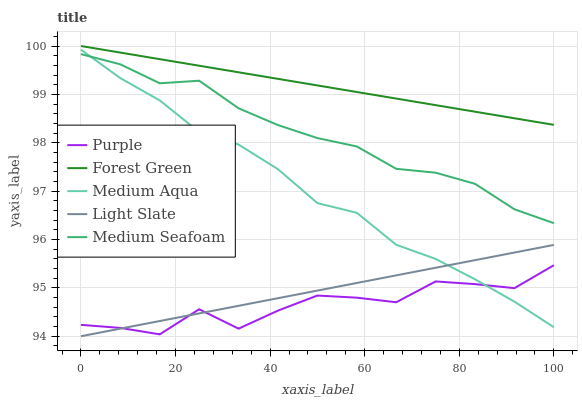Does Purple have the minimum area under the curve?
Answer yes or no. Yes. Does Forest Green have the maximum area under the curve?
Answer yes or no. Yes. Does Light Slate have the minimum area under the curve?
Answer yes or no. No. Does Light Slate have the maximum area under the curve?
Answer yes or no. No. Is Forest Green the smoothest?
Answer yes or no. Yes. Is Purple the roughest?
Answer yes or no. Yes. Is Light Slate the smoothest?
Answer yes or no. No. Is Light Slate the roughest?
Answer yes or no. No. Does Light Slate have the lowest value?
Answer yes or no. Yes. Does Forest Green have the lowest value?
Answer yes or no. No. Does Forest Green have the highest value?
Answer yes or no. Yes. Does Light Slate have the highest value?
Answer yes or no. No. Is Light Slate less than Medium Seafoam?
Answer yes or no. Yes. Is Forest Green greater than Medium Seafoam?
Answer yes or no. Yes. Does Purple intersect Light Slate?
Answer yes or no. Yes. Is Purple less than Light Slate?
Answer yes or no. No. Is Purple greater than Light Slate?
Answer yes or no. No. Does Light Slate intersect Medium Seafoam?
Answer yes or no. No. 